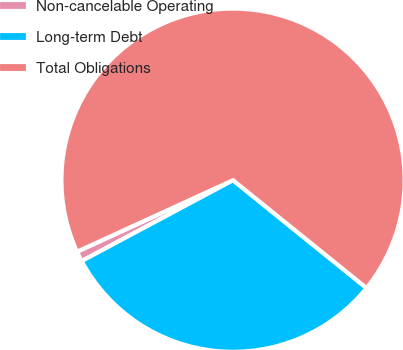Convert chart. <chart><loc_0><loc_0><loc_500><loc_500><pie_chart><fcel>Non-cancelable Operating<fcel>Long-term Debt<fcel>Total Obligations<nl><fcel>0.97%<fcel>31.38%<fcel>67.66%<nl></chart> 